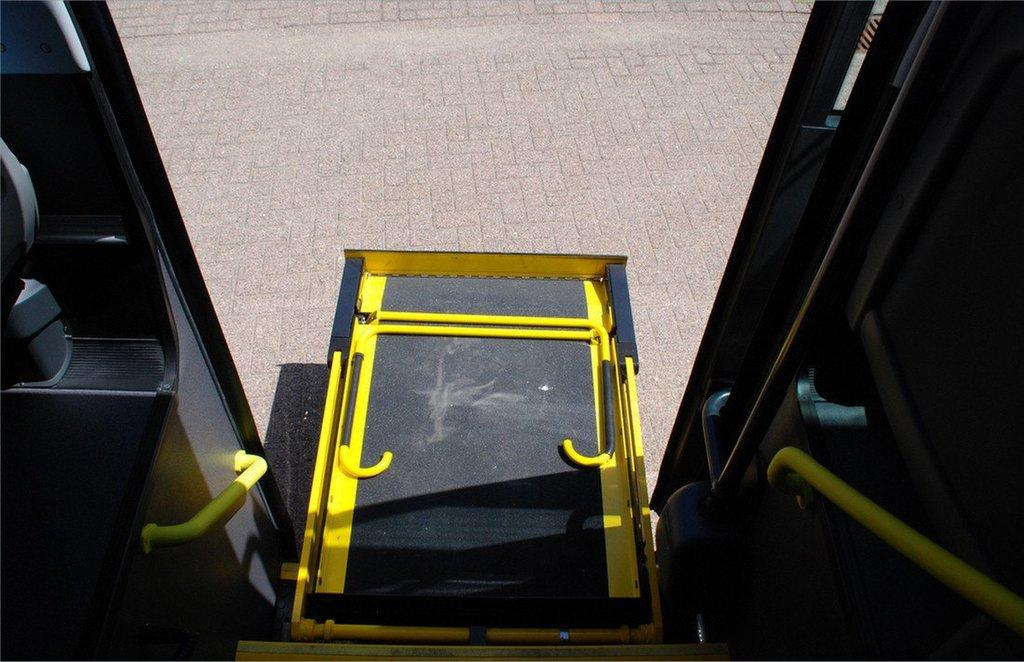What type of object is present in the image? There is a vehicle in the image. What colors are used for the vehicle? The vehicle is in black and yellow color. Are there any additional features associated with the vehicle? Yes, there are supportive rods associated with the vehicle. Can the vehicle be entered or exited? Yes, there is a door on the vehicle. What type of skirt is hanging on the vehicle in the image? There is no skirt present in the image; the vehicle is in black and yellow color with supportive rods and a door. 